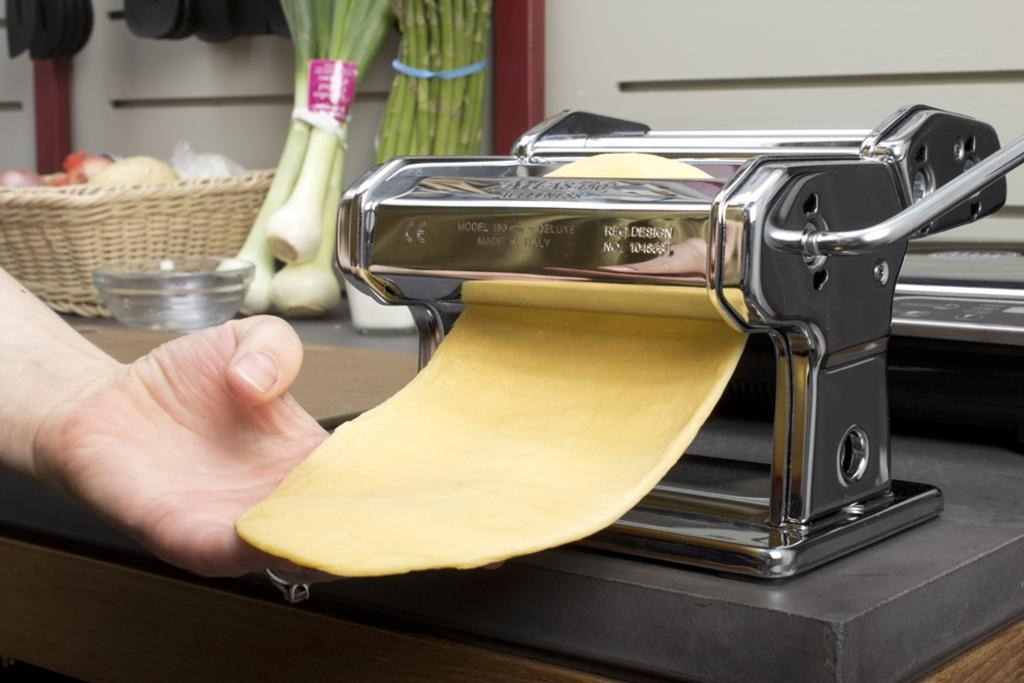Provide a one-sentence caption for the provided image. Someone makes pasta in a pasta maker that was made in Italy. 